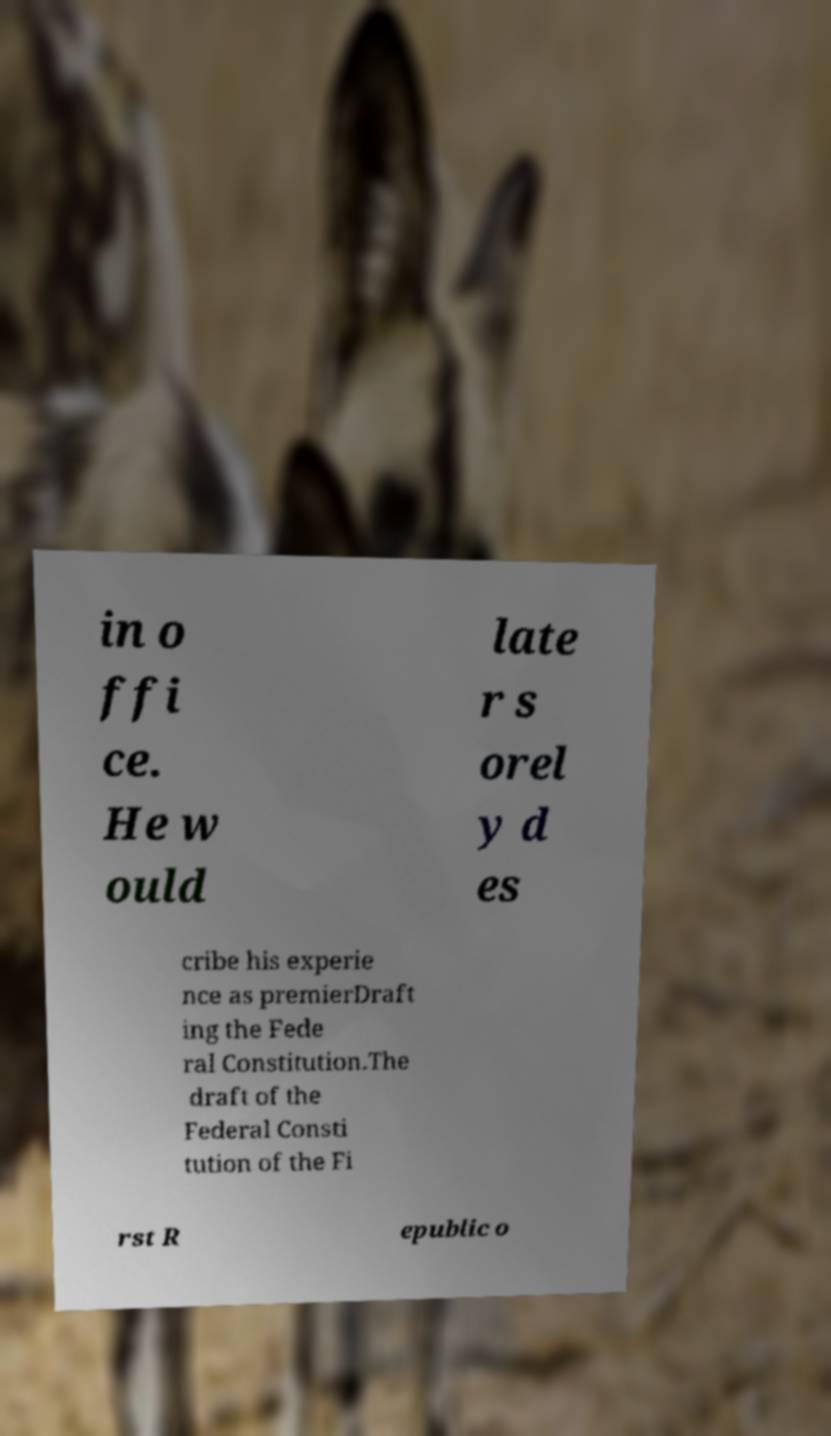Please identify and transcribe the text found in this image. in o ffi ce. He w ould late r s orel y d es cribe his experie nce as premierDraft ing the Fede ral Constitution.The draft of the Federal Consti tution of the Fi rst R epublic o 